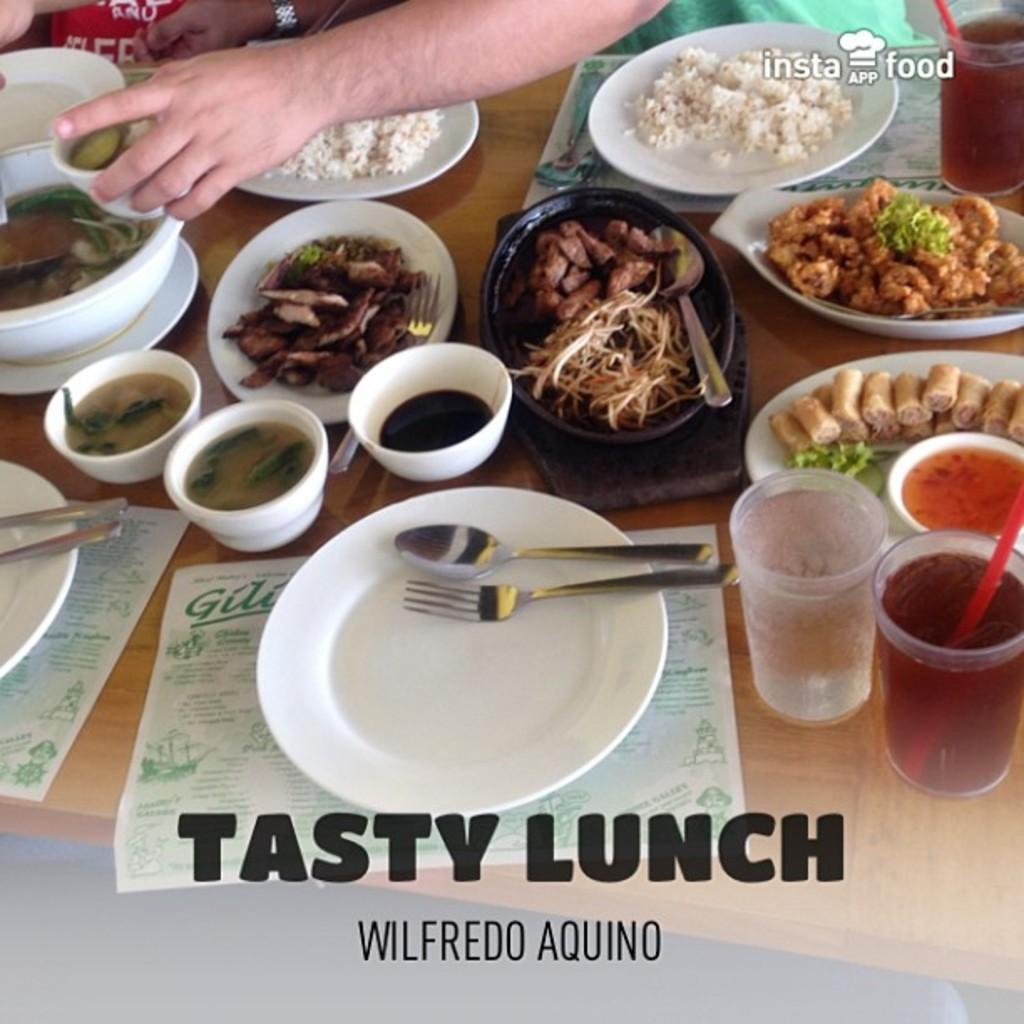Who or what is present in the image? There is a person in the image. What is the person interacting with in the image? The person is likely interacting with the table, as there are various items on it. What can be seen on the table in the image? There are bowls, plates, forks, spoons, glasses, and different types of dishes on the table. What type of scissors can be seen cutting the letters on the table in the image? There are no scissors or letters present in the image. How does the person's mouth look while eating in the image? There is no indication of the person eating or showing their mouth in the image. 